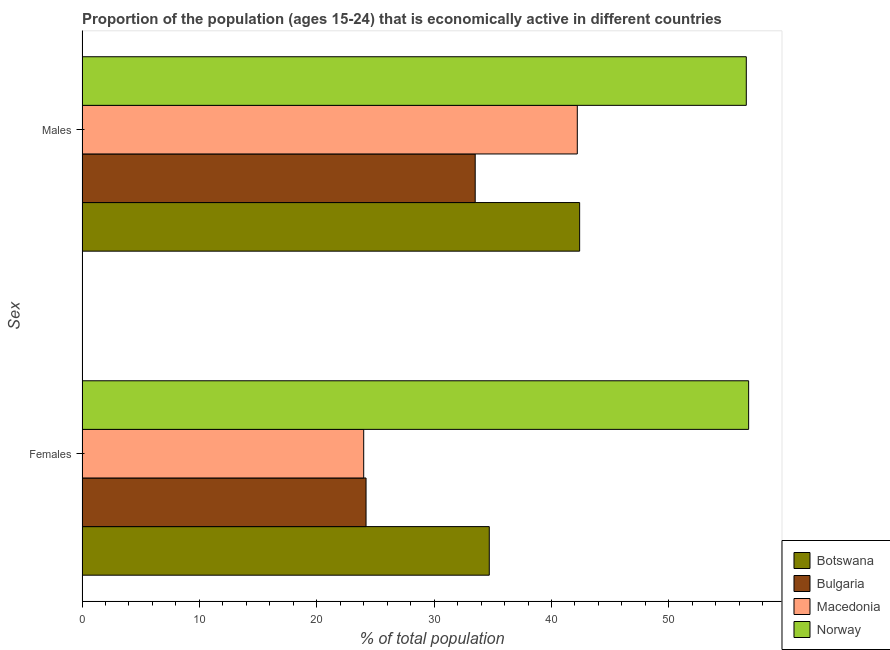What is the label of the 1st group of bars from the top?
Make the answer very short. Males. What is the percentage of economically active female population in Botswana?
Give a very brief answer. 34.7. Across all countries, what is the maximum percentage of economically active female population?
Offer a very short reply. 56.8. Across all countries, what is the minimum percentage of economically active male population?
Make the answer very short. 33.5. In which country was the percentage of economically active male population maximum?
Offer a terse response. Norway. What is the total percentage of economically active male population in the graph?
Make the answer very short. 174.7. What is the difference between the percentage of economically active female population in Botswana and that in Bulgaria?
Your response must be concise. 10.5. What is the difference between the percentage of economically active female population in Macedonia and the percentage of economically active male population in Botswana?
Your answer should be compact. -18.4. What is the average percentage of economically active male population per country?
Your response must be concise. 43.68. What is the difference between the percentage of economically active male population and percentage of economically active female population in Macedonia?
Offer a terse response. 18.2. What is the ratio of the percentage of economically active female population in Bulgaria to that in Norway?
Your response must be concise. 0.43. What does the 1st bar from the top in Males represents?
Provide a succinct answer. Norway. What does the 1st bar from the bottom in Females represents?
Your answer should be compact. Botswana. How many bars are there?
Provide a short and direct response. 8. Are all the bars in the graph horizontal?
Provide a succinct answer. Yes. How many countries are there in the graph?
Offer a terse response. 4. Are the values on the major ticks of X-axis written in scientific E-notation?
Provide a succinct answer. No. Does the graph contain grids?
Your answer should be compact. No. Where does the legend appear in the graph?
Offer a terse response. Bottom right. What is the title of the graph?
Your answer should be compact. Proportion of the population (ages 15-24) that is economically active in different countries. Does "Czech Republic" appear as one of the legend labels in the graph?
Provide a short and direct response. No. What is the label or title of the X-axis?
Provide a short and direct response. % of total population. What is the label or title of the Y-axis?
Your answer should be compact. Sex. What is the % of total population in Botswana in Females?
Keep it short and to the point. 34.7. What is the % of total population in Bulgaria in Females?
Make the answer very short. 24.2. What is the % of total population of Norway in Females?
Your response must be concise. 56.8. What is the % of total population in Botswana in Males?
Ensure brevity in your answer.  42.4. What is the % of total population in Bulgaria in Males?
Keep it short and to the point. 33.5. What is the % of total population in Macedonia in Males?
Your answer should be very brief. 42.2. What is the % of total population of Norway in Males?
Provide a short and direct response. 56.6. Across all Sex, what is the maximum % of total population in Botswana?
Ensure brevity in your answer.  42.4. Across all Sex, what is the maximum % of total population in Bulgaria?
Provide a succinct answer. 33.5. Across all Sex, what is the maximum % of total population in Macedonia?
Your answer should be compact. 42.2. Across all Sex, what is the maximum % of total population of Norway?
Your answer should be very brief. 56.8. Across all Sex, what is the minimum % of total population of Botswana?
Your answer should be compact. 34.7. Across all Sex, what is the minimum % of total population of Bulgaria?
Provide a succinct answer. 24.2. Across all Sex, what is the minimum % of total population in Norway?
Your response must be concise. 56.6. What is the total % of total population in Botswana in the graph?
Your answer should be compact. 77.1. What is the total % of total population of Bulgaria in the graph?
Offer a terse response. 57.7. What is the total % of total population in Macedonia in the graph?
Offer a terse response. 66.2. What is the total % of total population of Norway in the graph?
Offer a very short reply. 113.4. What is the difference between the % of total population of Botswana in Females and that in Males?
Ensure brevity in your answer.  -7.7. What is the difference between the % of total population in Bulgaria in Females and that in Males?
Give a very brief answer. -9.3. What is the difference between the % of total population in Macedonia in Females and that in Males?
Provide a succinct answer. -18.2. What is the difference between the % of total population of Botswana in Females and the % of total population of Bulgaria in Males?
Offer a terse response. 1.2. What is the difference between the % of total population of Botswana in Females and the % of total population of Norway in Males?
Offer a terse response. -21.9. What is the difference between the % of total population of Bulgaria in Females and the % of total population of Norway in Males?
Offer a terse response. -32.4. What is the difference between the % of total population in Macedonia in Females and the % of total population in Norway in Males?
Ensure brevity in your answer.  -32.6. What is the average % of total population of Botswana per Sex?
Offer a terse response. 38.55. What is the average % of total population of Bulgaria per Sex?
Make the answer very short. 28.85. What is the average % of total population in Macedonia per Sex?
Make the answer very short. 33.1. What is the average % of total population in Norway per Sex?
Provide a short and direct response. 56.7. What is the difference between the % of total population in Botswana and % of total population in Norway in Females?
Offer a very short reply. -22.1. What is the difference between the % of total population of Bulgaria and % of total population of Norway in Females?
Your response must be concise. -32.6. What is the difference between the % of total population in Macedonia and % of total population in Norway in Females?
Keep it short and to the point. -32.8. What is the difference between the % of total population of Botswana and % of total population of Bulgaria in Males?
Your response must be concise. 8.9. What is the difference between the % of total population of Bulgaria and % of total population of Norway in Males?
Offer a very short reply. -23.1. What is the difference between the % of total population of Macedonia and % of total population of Norway in Males?
Make the answer very short. -14.4. What is the ratio of the % of total population of Botswana in Females to that in Males?
Make the answer very short. 0.82. What is the ratio of the % of total population in Bulgaria in Females to that in Males?
Give a very brief answer. 0.72. What is the ratio of the % of total population in Macedonia in Females to that in Males?
Your response must be concise. 0.57. What is the difference between the highest and the second highest % of total population of Bulgaria?
Offer a very short reply. 9.3. What is the difference between the highest and the lowest % of total population in Macedonia?
Offer a very short reply. 18.2. 